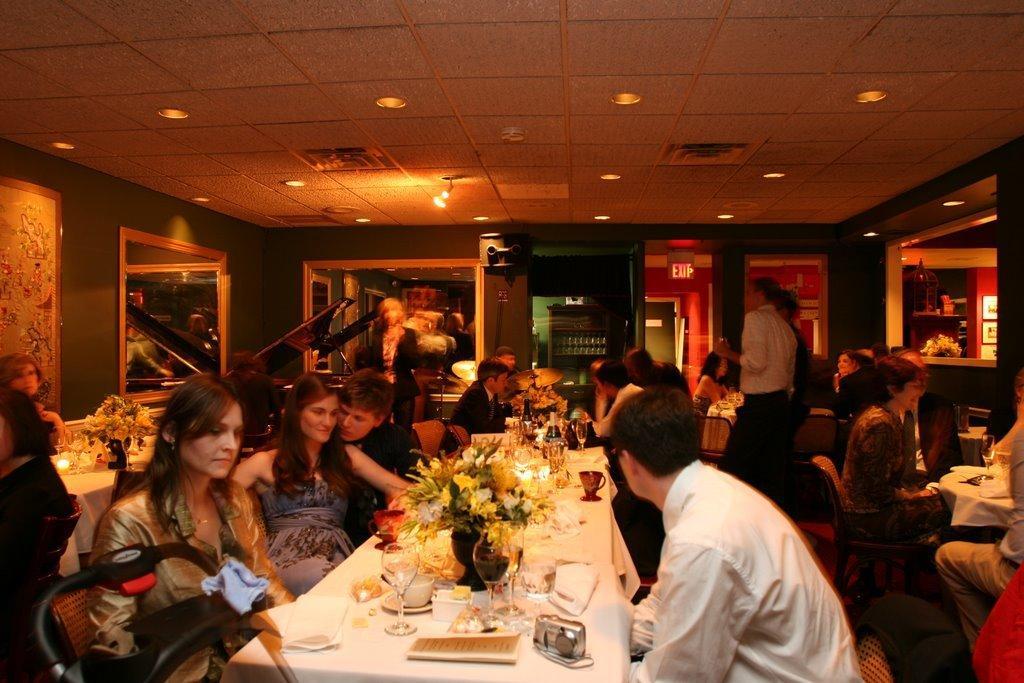How would you summarize this image in a sentence or two? in this image there is a big room some people they are sitting on the chair some people they are standing on the floor and some people could be talking each other and one table is the table has many things like flower vase,cups and radio glasses are there the back ground is very dark 